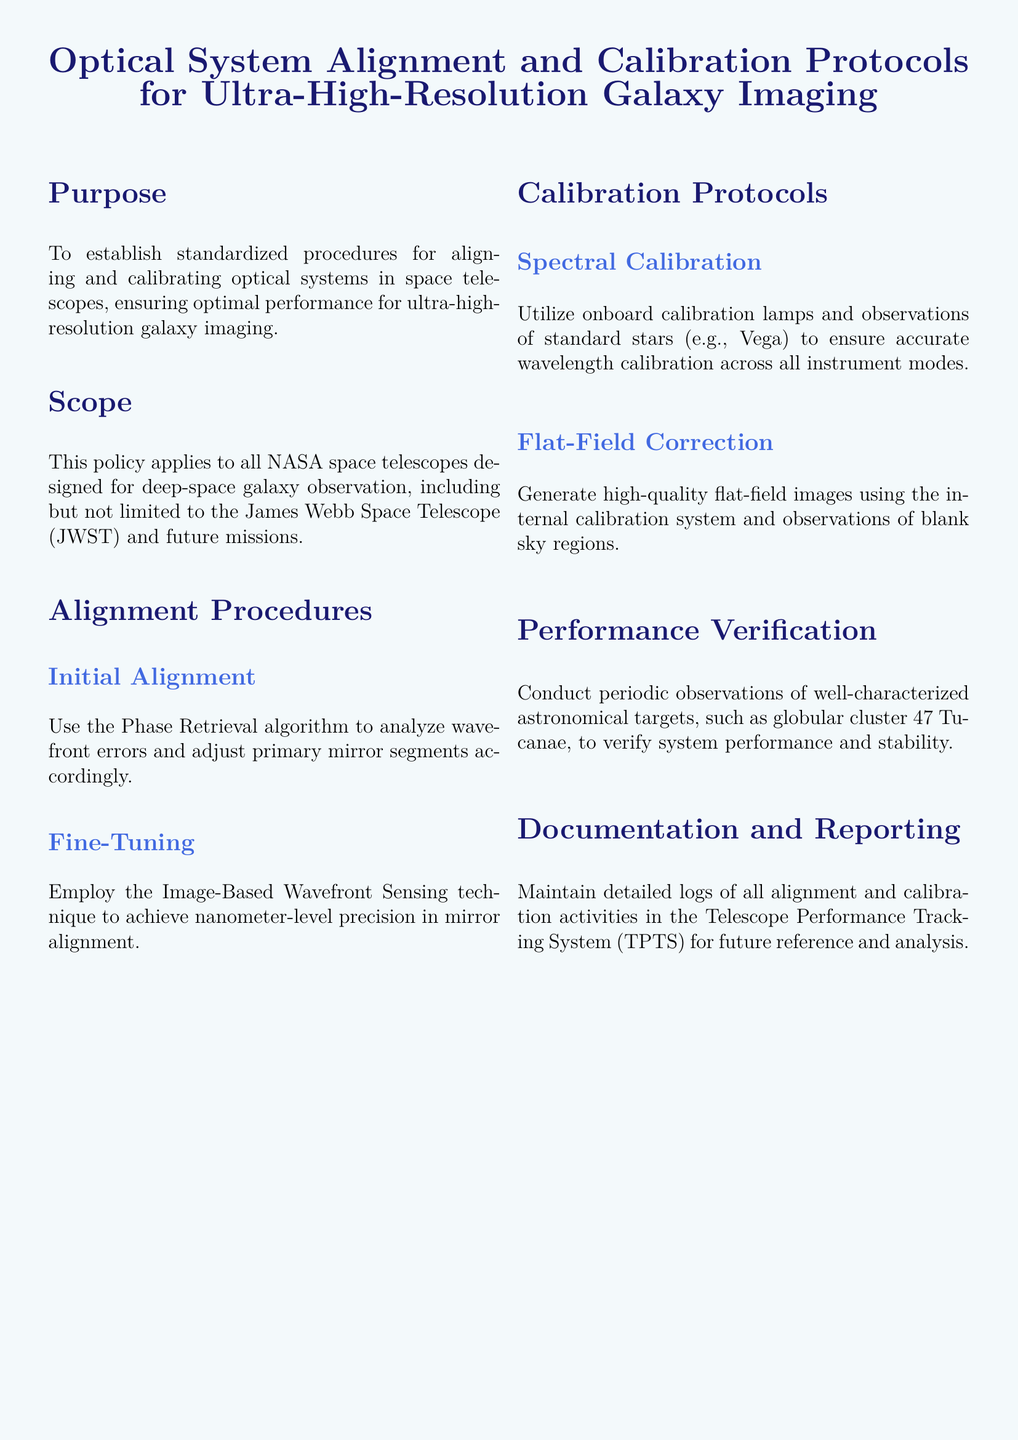What is the purpose of the document? The purpose is to establish standardized procedures for aligning and calibrating optical systems in space telescopes.
Answer: Standardized procedures for alignment and calibration Who does the policy apply to? The scope indicates that the policy applies to all NASA space telescopes designed for deep-space galaxy observation.
Answer: All NASA space telescopes What technique is used for fine-tuning mirror alignment? The document specifies the Image-Based Wavefront Sensing technique for achieving precision.
Answer: Image-Based Wavefront Sensing What celestial object is referenced for performance verification? The performance verification section mentions globular cluster 47 Tucanae as a target.
Answer: 47 Tucanae Which star is used for spectral calibration? The document lists Vega as a standard star for wavelength calibration.
Answer: Vega How are logs of alignment activities maintained? The documentation section states that logs are maintained in the Telescope Performance Tracking System.
Answer: Telescope Performance Tracking System What is the initial procedure for alignment? The initial alignment procedure includes using the Phase Retrieval algorithm to analyze wavefront errors.
Answer: Phase Retrieval algorithm What kind of images are generated for flat-field correction? The document mentions generating high-quality flat-field images using the internal calibration system.
Answer: High-quality flat-field images What is the aim of the calibration protocols? The aim of the calibration protocols is to ensure accurate wavelength calibration.
Answer: Ensure accurate wavelength calibration 